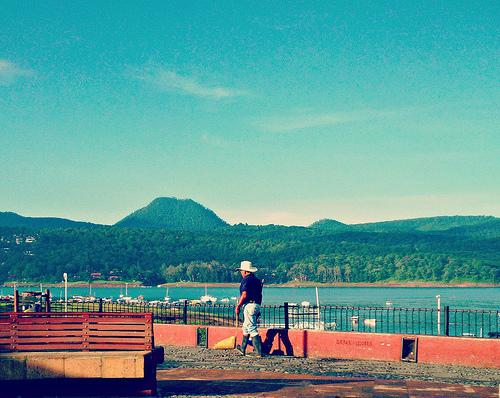Question: who is wearing a hat?
Choices:
A. The woman.
B. The baseball players.
C. The man.
D. The children.
Answer with the letter. Answer: C Question: what is the color of the man's shirt?
Choices:
A. Black.
B. Brown.
C. Blue.
D. Green.
Answer with the letter. Answer: C Question: how many boots is the man wearing?
Choices:
A. 1.
B. 3.
C. 0.
D. 2.
Answer with the letter. Answer: D Question: what color is the concrete attached to the metal fence?
Choices:
A. Red.
B. Orange.
C. Yellow.
D. White.
Answer with the letter. Answer: A 